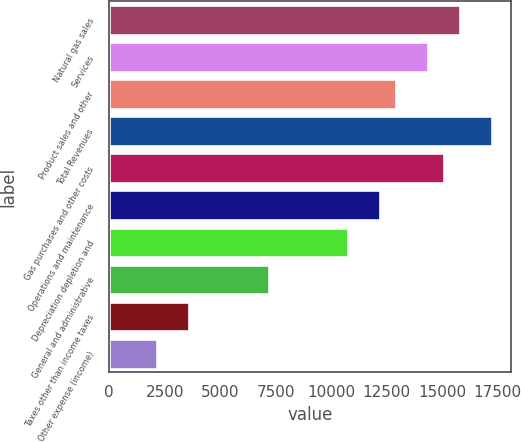Convert chart to OTSL. <chart><loc_0><loc_0><loc_500><loc_500><bar_chart><fcel>Natural gas sales<fcel>Services<fcel>Product sales and other<fcel>Total Revenues<fcel>Gas purchases and other costs<fcel>Operations and maintenance<fcel>Depreciation depletion and<fcel>General and administrative<fcel>Taxes other than income taxes<fcel>Other expense (income)<nl><fcel>15807.1<fcel>14370.1<fcel>12933.1<fcel>17244.1<fcel>15088.6<fcel>12214.6<fcel>10777.6<fcel>7185.2<fcel>3592.75<fcel>2155.77<nl></chart> 